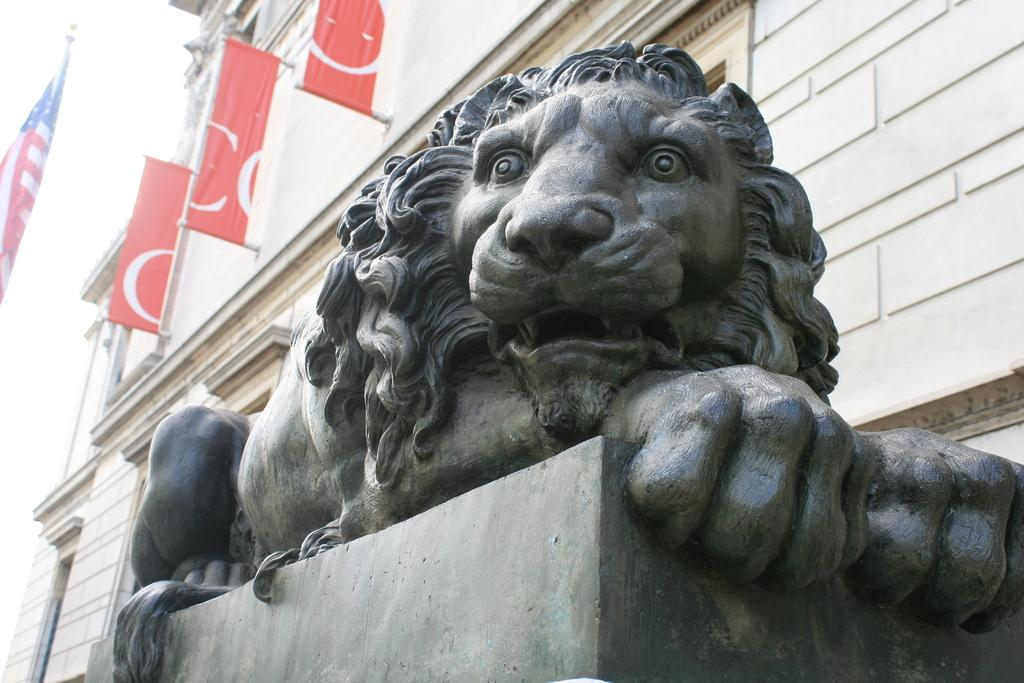What is the main subject in the image? There is a statue in the image. What is the statue standing on? There is a pedestal in the image. What type of structures can be seen in the image? There are buildings in the image. What other objects are present in the image? There are flags in the image. What is visible in the background of the image? The sky is visible in the image. Where are the children playing in the image? There are no children present in the image. What type of paste is being used in the image? There is no paste present in the image. 